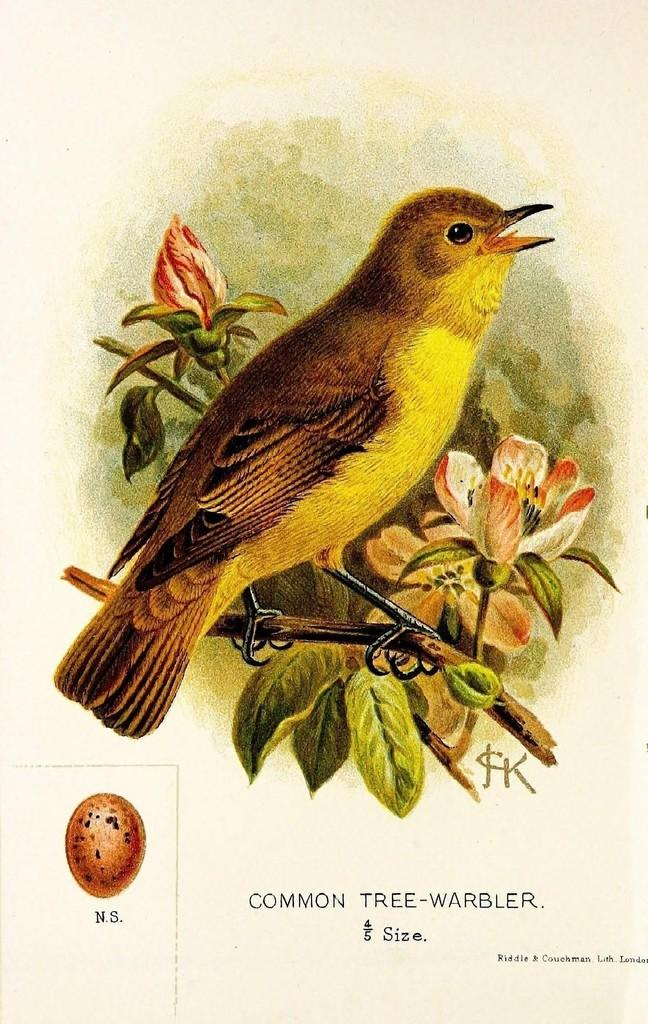What is the main subject of the paper in the image? The paper contains a painting that depicts a bird. What else can be seen in the painting on the paper? The painting also depicts a tree branch and flowers. What type of umbrella is being used by the bird in the painting? There is no umbrella present in the painting; the bird is depicted without any umbrella. How does the bird interact with the waves in the painting? There are no waves present in the painting; the bird is depicted near a tree branch and flowers. 